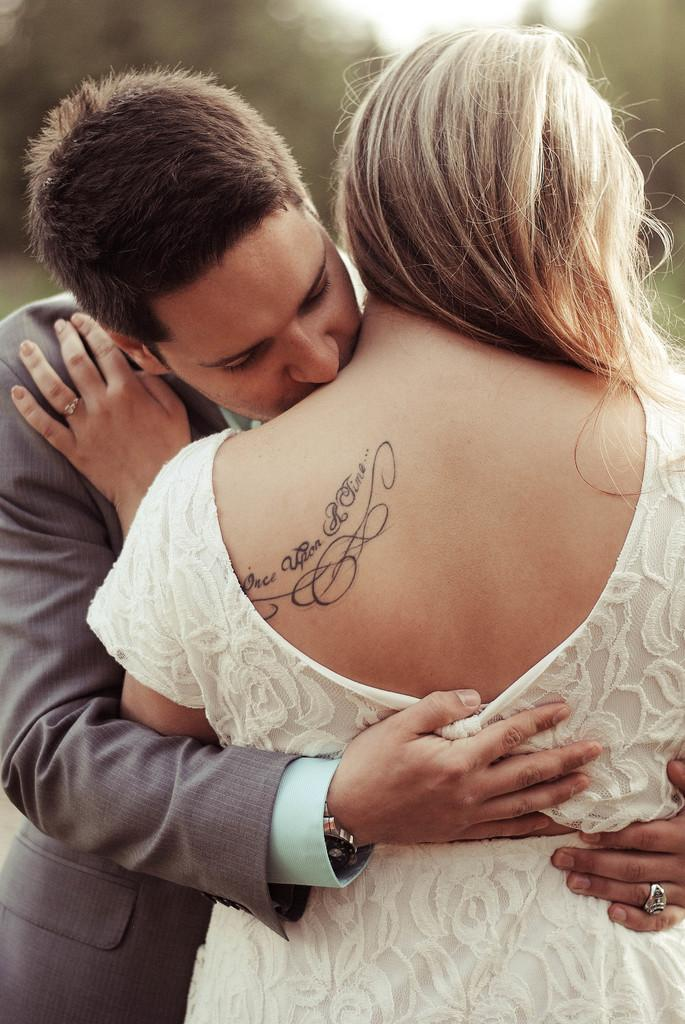What is happening between the two people in the image? The couple is hugging each other in the image. What is the lady wearing in the image? The lady is wearing a white dress in the image. Can you describe any unique features of the lady? The lady has a tattoo in the image. How would you describe the background of the image? The background of the image is blurred. What type of coast can be seen in the background of the image? There is no coast visible in the background of the image; it is blurred. 